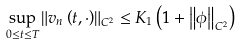Convert formula to latex. <formula><loc_0><loc_0><loc_500><loc_500>\sup _ { 0 \leq t \leq T } \left \| v _ { n } \left ( t , \cdot \right ) \right \| _ { C ^ { 2 } } \leq K _ { 1 } \left ( 1 + \left \| \phi \right \| _ { C ^ { 2 } } \right )</formula> 